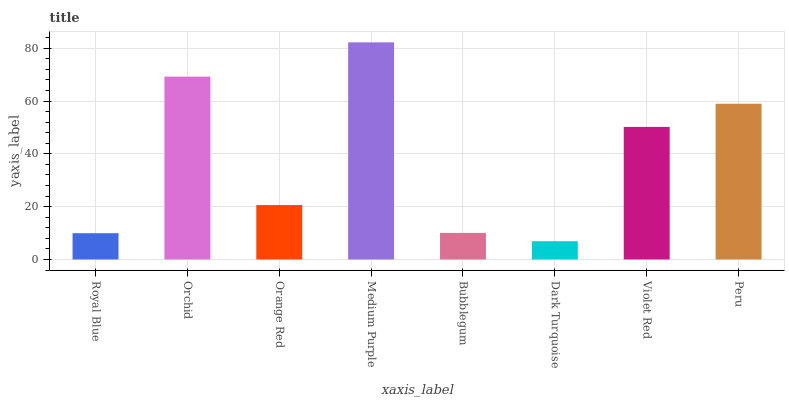Is Dark Turquoise the minimum?
Answer yes or no. Yes. Is Medium Purple the maximum?
Answer yes or no. Yes. Is Orchid the minimum?
Answer yes or no. No. Is Orchid the maximum?
Answer yes or no. No. Is Orchid greater than Royal Blue?
Answer yes or no. Yes. Is Royal Blue less than Orchid?
Answer yes or no. Yes. Is Royal Blue greater than Orchid?
Answer yes or no. No. Is Orchid less than Royal Blue?
Answer yes or no. No. Is Violet Red the high median?
Answer yes or no. Yes. Is Orange Red the low median?
Answer yes or no. Yes. Is Bubblegum the high median?
Answer yes or no. No. Is Bubblegum the low median?
Answer yes or no. No. 